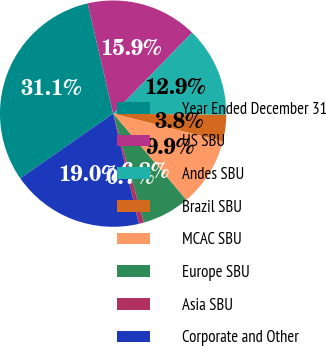Convert chart to OTSL. <chart><loc_0><loc_0><loc_500><loc_500><pie_chart><fcel>Year Ended December 31<fcel>US SBU<fcel>Andes SBU<fcel>Brazil SBU<fcel>MCAC SBU<fcel>Europe SBU<fcel>Asia SBU<fcel>Corporate and Other<nl><fcel>31.08%<fcel>15.91%<fcel>12.88%<fcel>3.78%<fcel>9.85%<fcel>6.81%<fcel>0.74%<fcel>18.95%<nl></chart> 